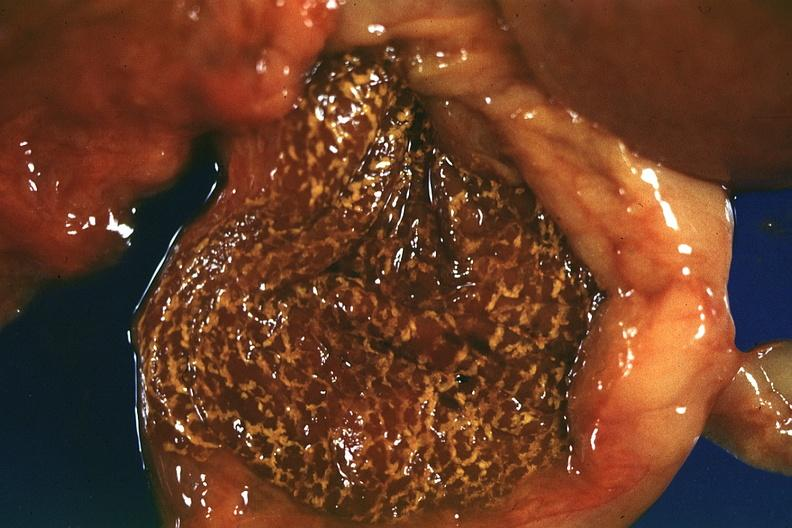what is present?
Answer the question using a single word or phrase. Hepatobiliary 